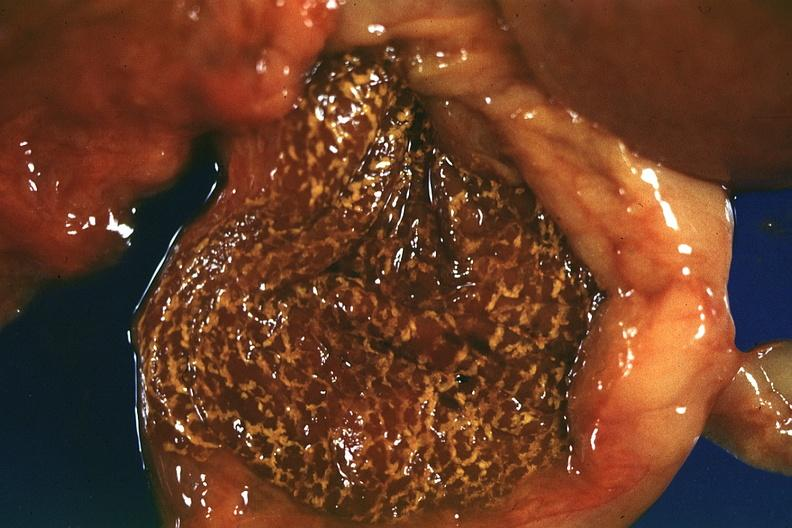what is present?
Answer the question using a single word or phrase. Hepatobiliary 